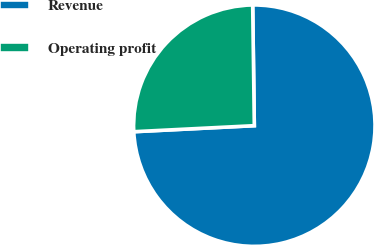<chart> <loc_0><loc_0><loc_500><loc_500><pie_chart><fcel>Revenue<fcel>Operating profit<nl><fcel>74.42%<fcel>25.58%<nl></chart> 